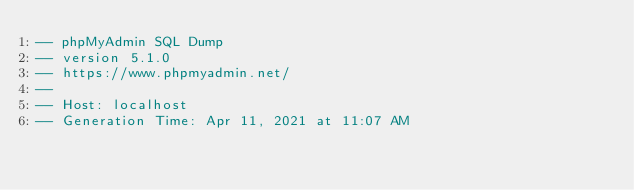<code> <loc_0><loc_0><loc_500><loc_500><_SQL_>-- phpMyAdmin SQL Dump
-- version 5.1.0
-- https://www.phpmyadmin.net/
--
-- Host: localhost
-- Generation Time: Apr 11, 2021 at 11:07 AM</code> 